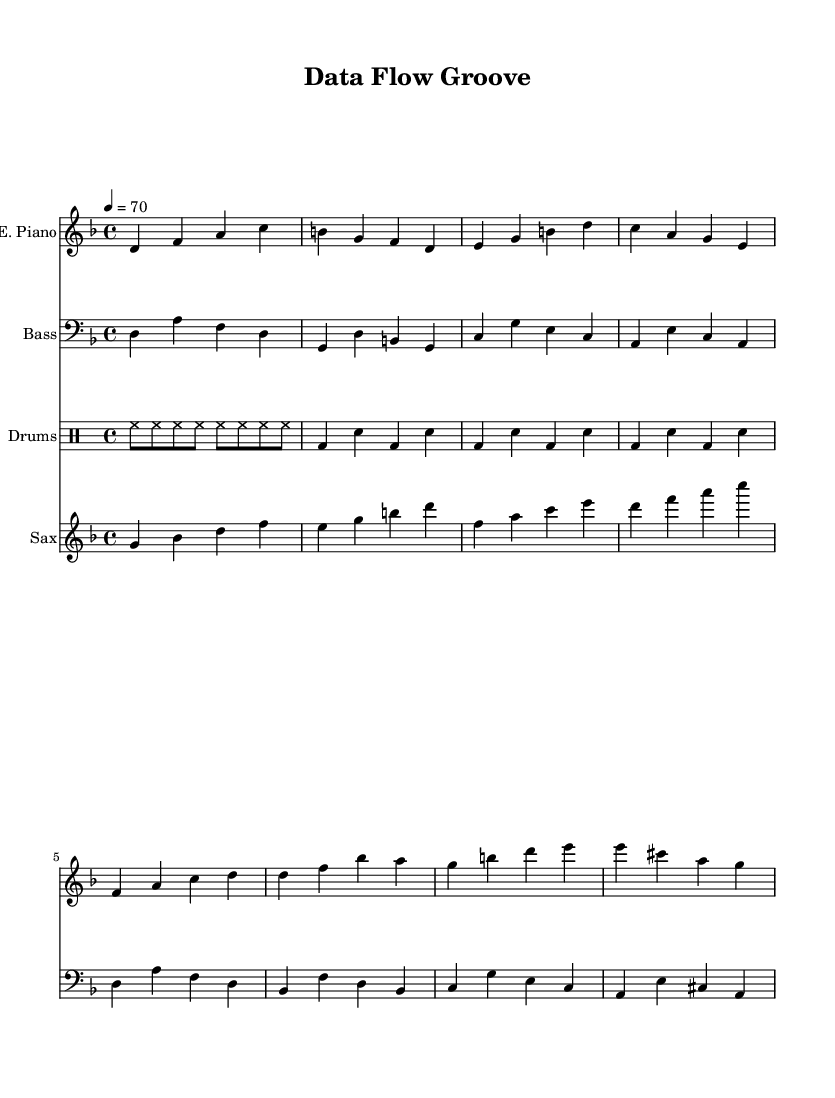What is the key signature of this music? The key signature is D minor, which has one flat (B flat). This can be identified by looking at the beginning of the staff, where the flat symbol appears before the notes.
Answer: D minor What is the time signature of this piece? The time signature is 4/4, indicated at the beginning of the sheet music. This means there are four beats in a measure and a quarter note gets one beat.
Answer: 4/4 What is the tempo marking for the music? The tempo marking is 4 = 70, which signifies that the quarter note should be played at a speed of 70 beats per minute. This information is located at the beginning of the score.
Answer: 70 How many measures are in the verse section? The verse section consists of four measures, which can be counted by observing the segment labeled "Verse" in the electric piano and bass guitar parts.
Answer: 4 What instrument plays the bridge section? The saxophone plays the bridge section, as indicated in the score where the saxophone part begins with a different set of notes labeled "Bridge".
Answer: Saxophone Which instrument is indicated to play a groove with a basic rhythm pattern? The drums are indicated to play a groove with a basic rhythm pattern, as shown in the drummode section of the score. The pattern suggests a percussive backbone typical of R&B music.
Answer: Drums What characteristic element does R&B music incorporate in this piece? The piece incorporates smooth jazz elements, as evident from the use of the saxophone and the laid-back groove established by the rhythms in the drum and bass parts, characteristic of the R&B genre.
Answer: Smooth jazz 